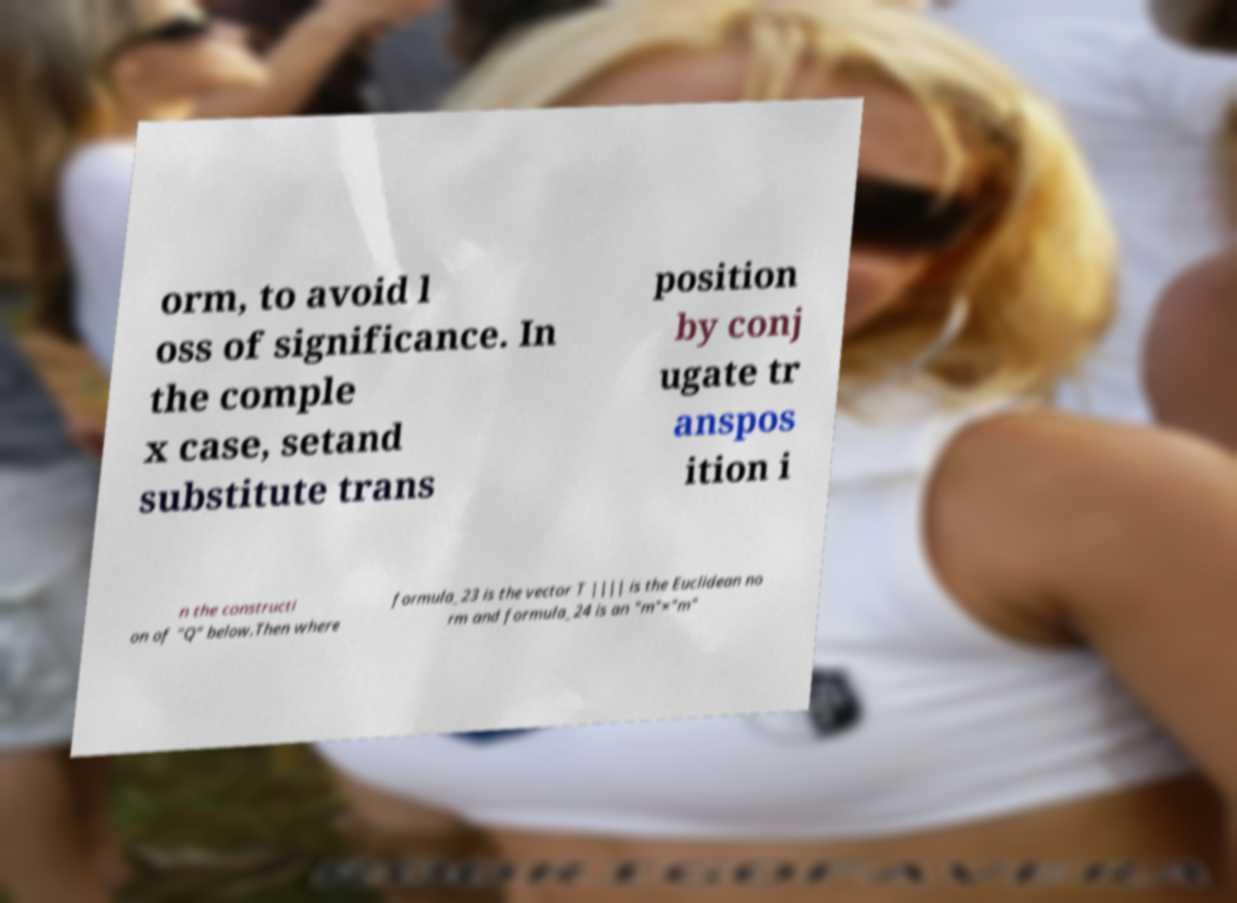Can you read and provide the text displayed in the image?This photo seems to have some interesting text. Can you extract and type it out for me? orm, to avoid l oss of significance. In the comple x case, setand substitute trans position by conj ugate tr anspos ition i n the constructi on of "Q" below.Then where formula_23 is the vector T |||| is the Euclidean no rm and formula_24 is an "m"×"m" 